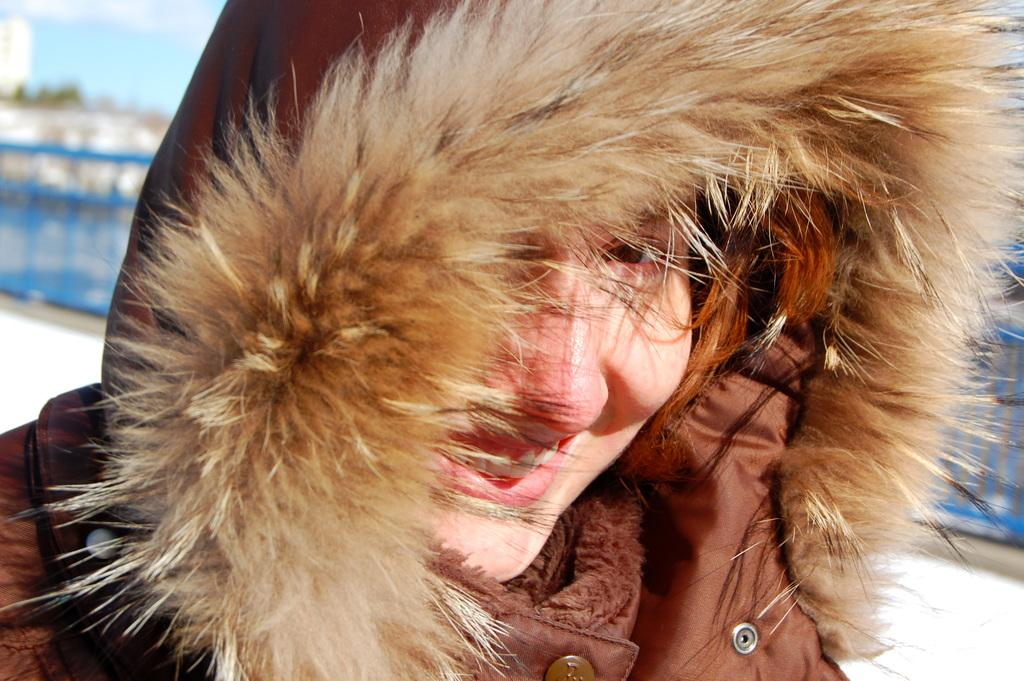Who is present in the image? There is a woman in the image. What is the woman's facial expression? The woman is smiling. What can be seen in the background of the image? There is a fence, trees, and the sky visible in the background of the image. How would you describe the quality of the image? The image is blurry. What scent can be detected in the image? There is no information about a scent in the image, as it is a visual medium. 